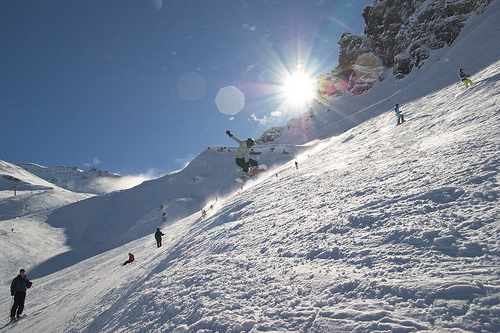How does the sunlight affect the visual perception of this photograph? The sunlight creates strong contrasts between light and shadow on the snow, enhancing the textures and depth of the landscape. Lens flares are present, adding a dreamy quality to the image while also slightly obscuring details. What does the presence of people in the image suggest about the location? The presence of active snowboarders and skiers suggests that this location is a popular area for winter sports, possibly a mountain resort designed for such recreational activities, frequented by enthusiasts and professionals alike. 